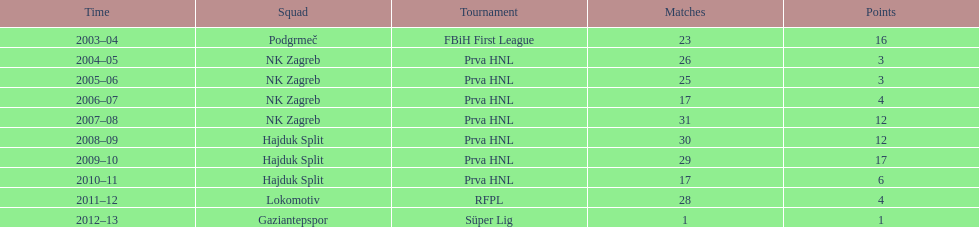Was ibricic's goal count higher or lower in his 3 seasons with hajduk split in comparison to his 4 seasons with nk zagreb? More. 